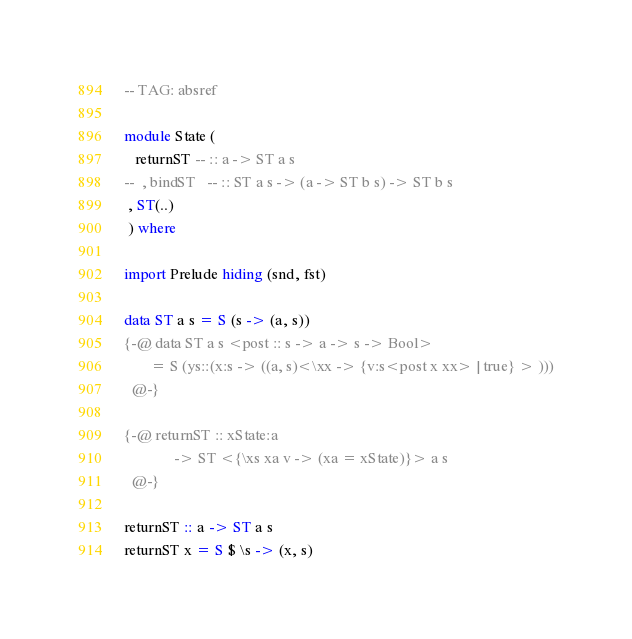Convert code to text. <code><loc_0><loc_0><loc_500><loc_500><_Haskell_>-- TAG: absref

module State (
   returnST -- :: a -> ST a s
--  , bindST   -- :: ST a s -> (a -> ST b s) -> ST b s
 , ST(..)
 ) where

import Prelude hiding (snd, fst)

data ST a s = S (s -> (a, s))
{-@ data ST a s <post :: s -> a -> s -> Bool> 
       = S (ys::(x:s -> ((a, s)<\xx -> {v:s<post x xx> | true} > )))
  @-}

{-@ returnST :: xState:a 
             -> ST <{\xs xa v -> (xa = xState)}> a s 
  @-}

returnST :: a -> ST a s
returnST x = S $ \s -> (x, s)
</code> 